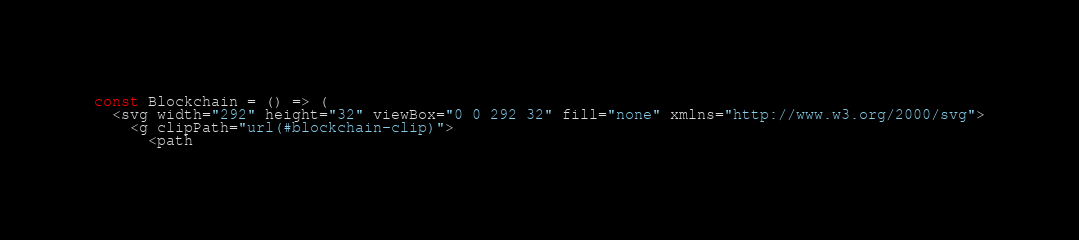Convert code to text. <code><loc_0><loc_0><loc_500><loc_500><_JavaScript_>const Blockchain = () => (
  <svg width="292" height="32" viewBox="0 0 292 32" fill="none" xmlns="http://www.w3.org/2000/svg">
    <g clipPath="url(#blockchain-clip)">
      <path</code> 